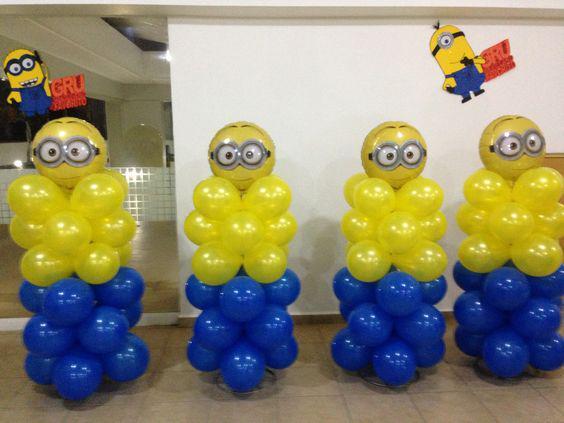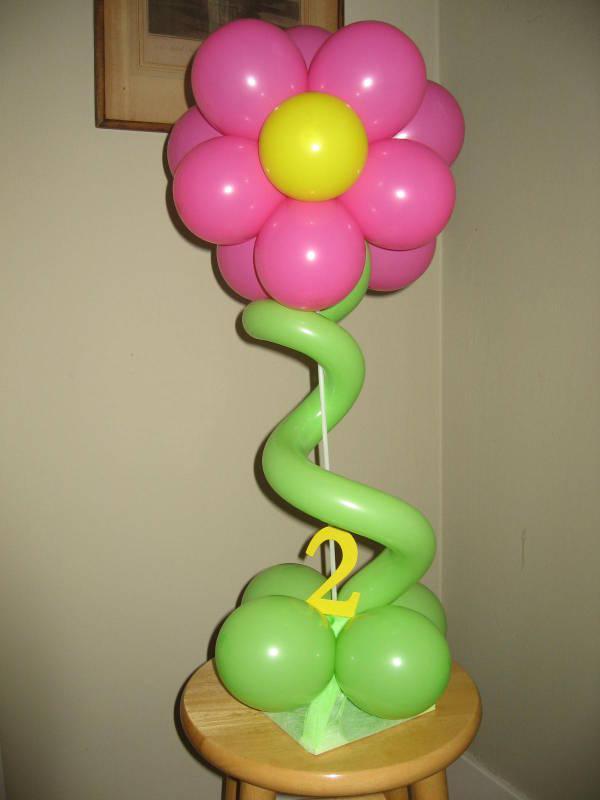The first image is the image on the left, the second image is the image on the right. Given the left and right images, does the statement "Some balloons have faces." hold true? Answer yes or no. Yes. The first image is the image on the left, the second image is the image on the right. Considering the images on both sides, is "Both images have letters." valid? Answer yes or no. No. 